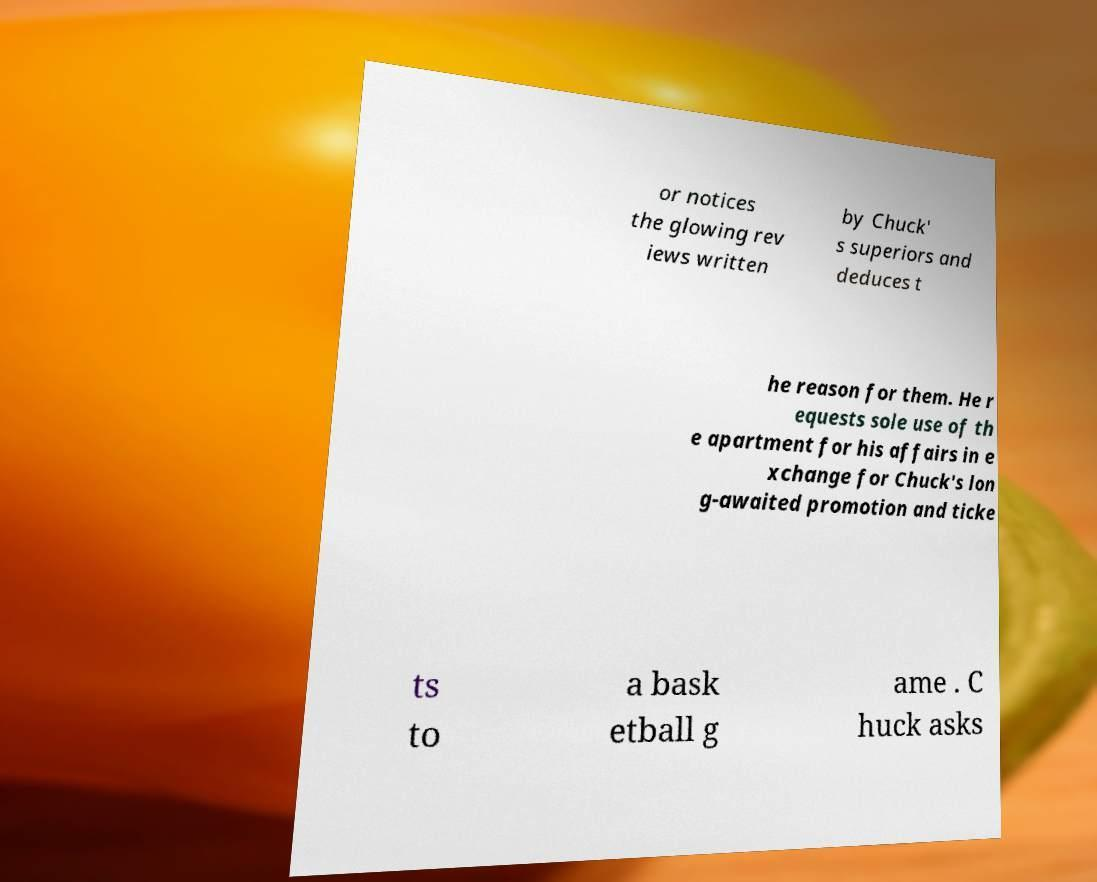Can you read and provide the text displayed in the image?This photo seems to have some interesting text. Can you extract and type it out for me? or notices the glowing rev iews written by Chuck' s superiors and deduces t he reason for them. He r equests sole use of th e apartment for his affairs in e xchange for Chuck's lon g-awaited promotion and ticke ts to a bask etball g ame . C huck asks 